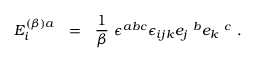<formula> <loc_0><loc_0><loc_500><loc_500>E _ { i } ^ { ( \beta ) a } = \frac { 1 } { \beta } \epsilon ^ { a b c } \epsilon _ { i j k } e _ { j } ^ { b } e _ { k } ^ { c } .</formula> 